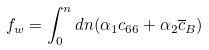<formula> <loc_0><loc_0><loc_500><loc_500>f _ { w } = \int _ { 0 } ^ { n } d n ( \alpha _ { 1 } c _ { 6 6 } + \alpha _ { 2 } \overline { c } _ { B } )</formula> 